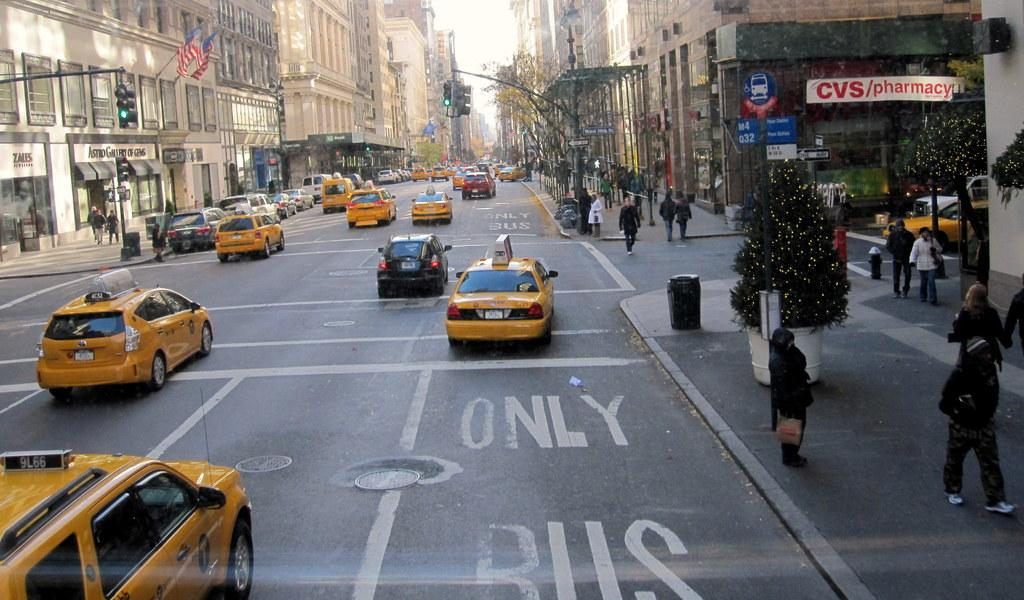<image>
Summarize the visual content of the image. A taxi turns a corner from a Bus Only lane near a CVS pharmacy. 